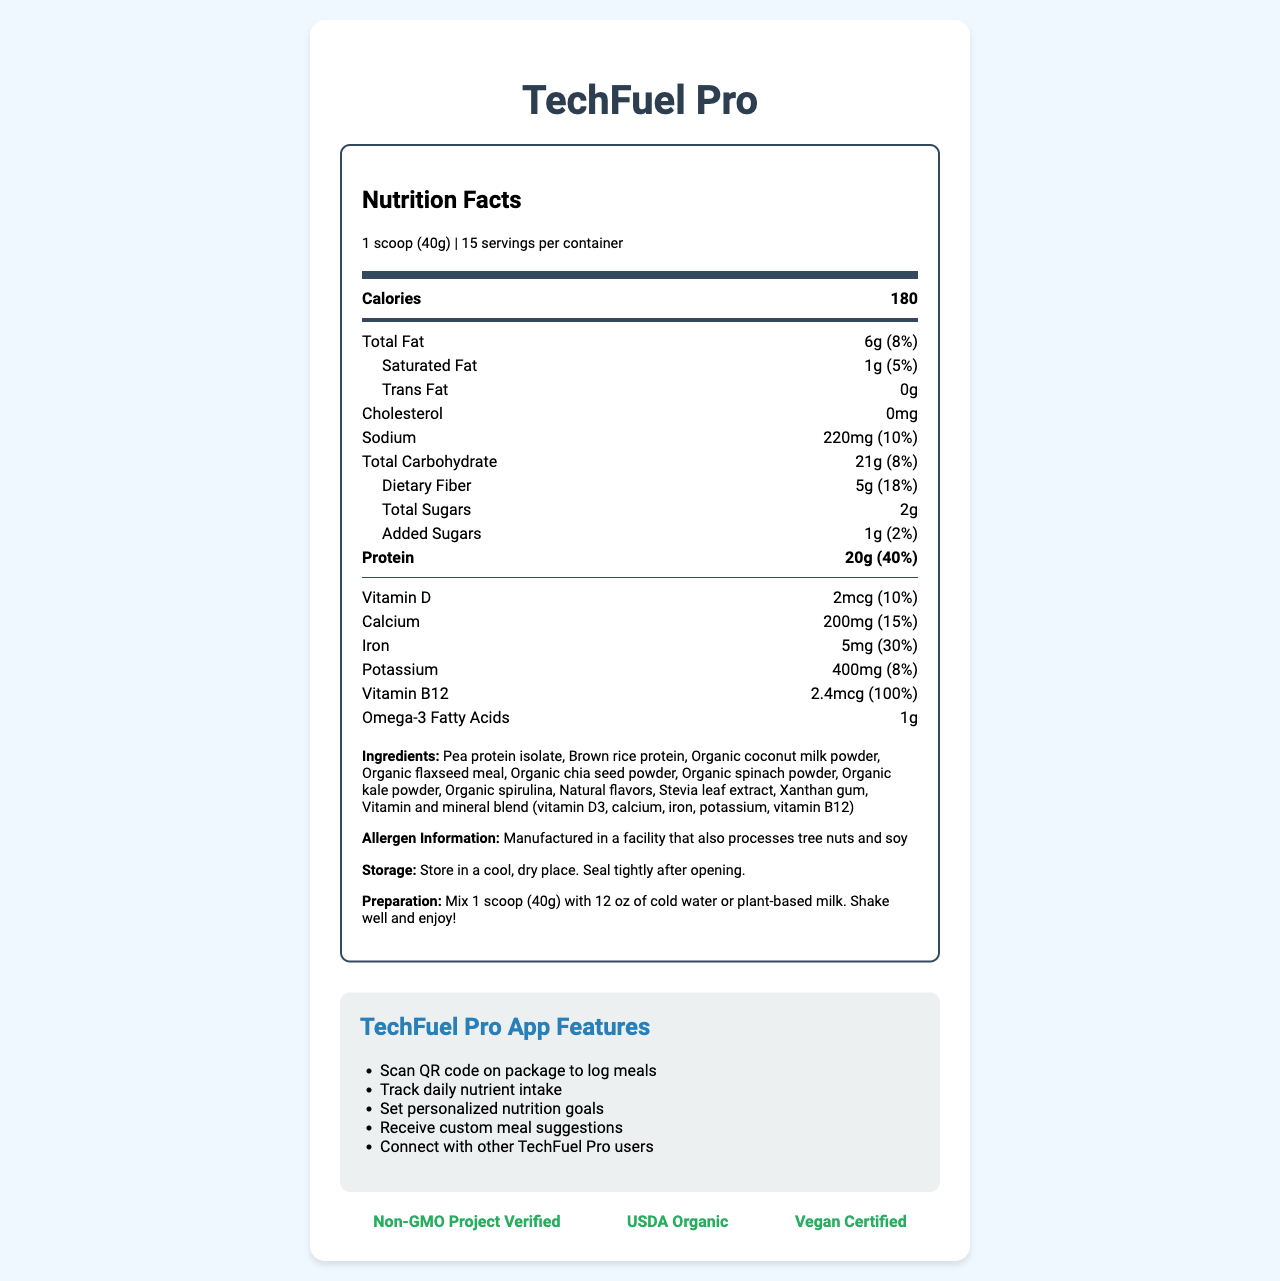what is the serving size of TechFuel Pro? The serving size is explicitly stated in the document under the nutrition facts section.
Answer: 1 scoop (40g) how many calories are in one serving of TechFuel Pro? The calorie content per serving is mentioned in the nutrition facts section.
Answer: 180 what is the daily value percentage of dietary fiber in one serving? The daily value percentage for dietary fiber is listed clearly under the nutrition facts section.
Answer: 18% name three ingredients in TechFuel Pro. The ingredients are listed in the document.
Answer: Pea protein isolate, Brown rice protein, Organic coconut milk powder how much protein does one serving of TechFuel Pro contain? The protein content per serving is detailed in the nutrition facts section.
Answer: 20g what certifications does TechFuel Pro have? A. USDA Organic B. Vegan Certified C. Both A & B D. Certified Gluten-Free The document lists USDA Organic and Vegan Certified under certifications.
Answer: C which feature is NOT part of the TechFuel Pro app? A. Log meals B. Track daily nutrient intake C. Connect with a nutritionist D. Set personalized nutrition goals The feature to "Connect with a nutritionist" is not listed; the features are mentioned under the app features section.
Answer: C does TechFuel Pro contain any trans fat? (Yes/No) The trans fat content is listed as 0g in the nutrition facts section.
Answer: No summarize the main benefits of using TechFuel Pro. The document outlines the product's purpose, key benefits, nutritional content, and app features.
Answer: TechFuel Pro is a plant-based meal replacement shake designed for tech-savvy professionals, offering cognitive support, sustained energy, muscle recovery, and enhanced focus. It provides various nutrients, is easy to prepare, and includes app features like meal logging and tracking nutrient intake. what is the recommended storage instruction for TechFuel Pro? The storage instructions are provided in the document.
Answer: Store in a cool, dry place. Seal tightly after opening. what is the price of TechFuel Pro per container? The document does not provide any pricing information.
Answer: Cannot be determined how many servings does one container of TechFuel Pro hold? The number of servings per container is specified in the nutrition facts section.
Answer: 15 which nutrient contributes the highest percentage of daily value per serving? The document shows that protein has a daily value percentage of 40%, the highest among the listed nutrients.
Answer: Protein name two vitamins included in TechFuel Pro. The document lists vitamin D and vitamin B12 in the nutrition facts section.
Answer: Vitamin D, Vitamin B12 how long should TechFuel Pro be stored after opening? The document advises sealing tightly after opening and storing in a cool, dry place but does not specify a time.
Answer: Not specified 